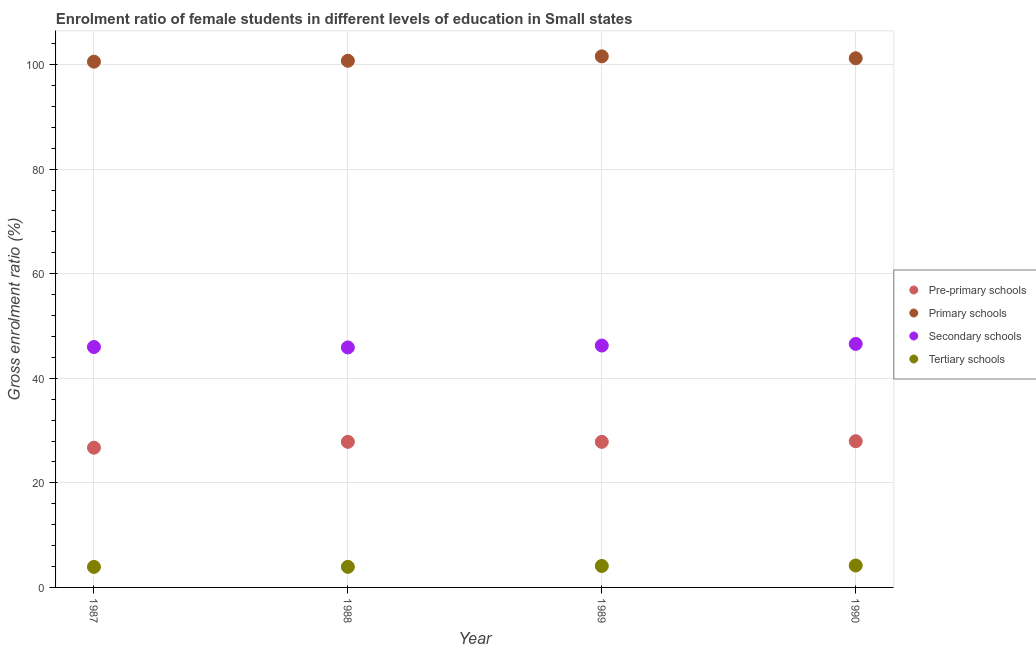How many different coloured dotlines are there?
Ensure brevity in your answer.  4. What is the gross enrolment ratio(male) in tertiary schools in 1990?
Provide a short and direct response. 4.19. Across all years, what is the maximum gross enrolment ratio(male) in primary schools?
Provide a succinct answer. 101.56. Across all years, what is the minimum gross enrolment ratio(male) in tertiary schools?
Offer a terse response. 3.93. In which year was the gross enrolment ratio(male) in primary schools maximum?
Your answer should be compact. 1989. What is the total gross enrolment ratio(male) in tertiary schools in the graph?
Provide a succinct answer. 16.16. What is the difference between the gross enrolment ratio(male) in pre-primary schools in 1988 and that in 1989?
Keep it short and to the point. 0.01. What is the difference between the gross enrolment ratio(male) in tertiary schools in 1989 and the gross enrolment ratio(male) in secondary schools in 1987?
Keep it short and to the point. -41.87. What is the average gross enrolment ratio(male) in tertiary schools per year?
Give a very brief answer. 4.04. In the year 1988, what is the difference between the gross enrolment ratio(male) in secondary schools and gross enrolment ratio(male) in primary schools?
Keep it short and to the point. -54.82. What is the ratio of the gross enrolment ratio(male) in secondary schools in 1989 to that in 1990?
Give a very brief answer. 0.99. Is the gross enrolment ratio(male) in primary schools in 1987 less than that in 1990?
Ensure brevity in your answer.  Yes. Is the difference between the gross enrolment ratio(male) in secondary schools in 1987 and 1988 greater than the difference between the gross enrolment ratio(male) in primary schools in 1987 and 1988?
Give a very brief answer. Yes. What is the difference between the highest and the second highest gross enrolment ratio(male) in tertiary schools?
Your answer should be compact. 0.09. What is the difference between the highest and the lowest gross enrolment ratio(male) in pre-primary schools?
Provide a short and direct response. 1.24. In how many years, is the gross enrolment ratio(male) in pre-primary schools greater than the average gross enrolment ratio(male) in pre-primary schools taken over all years?
Offer a very short reply. 3. Is the sum of the gross enrolment ratio(male) in pre-primary schools in 1987 and 1990 greater than the maximum gross enrolment ratio(male) in secondary schools across all years?
Offer a terse response. Yes. How many years are there in the graph?
Ensure brevity in your answer.  4. What is the difference between two consecutive major ticks on the Y-axis?
Your response must be concise. 20. Where does the legend appear in the graph?
Your response must be concise. Center right. How are the legend labels stacked?
Ensure brevity in your answer.  Vertical. What is the title of the graph?
Your answer should be compact. Enrolment ratio of female students in different levels of education in Small states. What is the label or title of the X-axis?
Your answer should be very brief. Year. What is the label or title of the Y-axis?
Your response must be concise. Gross enrolment ratio (%). What is the Gross enrolment ratio (%) in Pre-primary schools in 1987?
Make the answer very short. 26.72. What is the Gross enrolment ratio (%) of Primary schools in 1987?
Give a very brief answer. 100.54. What is the Gross enrolment ratio (%) of Secondary schools in 1987?
Your response must be concise. 45.98. What is the Gross enrolment ratio (%) in Tertiary schools in 1987?
Your answer should be compact. 3.93. What is the Gross enrolment ratio (%) of Pre-primary schools in 1988?
Make the answer very short. 27.85. What is the Gross enrolment ratio (%) of Primary schools in 1988?
Your response must be concise. 100.71. What is the Gross enrolment ratio (%) of Secondary schools in 1988?
Offer a very short reply. 45.89. What is the Gross enrolment ratio (%) in Tertiary schools in 1988?
Offer a terse response. 3.93. What is the Gross enrolment ratio (%) in Pre-primary schools in 1989?
Your response must be concise. 27.84. What is the Gross enrolment ratio (%) in Primary schools in 1989?
Keep it short and to the point. 101.56. What is the Gross enrolment ratio (%) in Secondary schools in 1989?
Offer a terse response. 46.26. What is the Gross enrolment ratio (%) of Tertiary schools in 1989?
Keep it short and to the point. 4.1. What is the Gross enrolment ratio (%) of Pre-primary schools in 1990?
Your answer should be compact. 27.96. What is the Gross enrolment ratio (%) in Primary schools in 1990?
Make the answer very short. 101.2. What is the Gross enrolment ratio (%) in Secondary schools in 1990?
Keep it short and to the point. 46.57. What is the Gross enrolment ratio (%) in Tertiary schools in 1990?
Your answer should be compact. 4.19. Across all years, what is the maximum Gross enrolment ratio (%) in Pre-primary schools?
Ensure brevity in your answer.  27.96. Across all years, what is the maximum Gross enrolment ratio (%) of Primary schools?
Ensure brevity in your answer.  101.56. Across all years, what is the maximum Gross enrolment ratio (%) in Secondary schools?
Provide a short and direct response. 46.57. Across all years, what is the maximum Gross enrolment ratio (%) in Tertiary schools?
Provide a succinct answer. 4.19. Across all years, what is the minimum Gross enrolment ratio (%) of Pre-primary schools?
Make the answer very short. 26.72. Across all years, what is the minimum Gross enrolment ratio (%) of Primary schools?
Give a very brief answer. 100.54. Across all years, what is the minimum Gross enrolment ratio (%) in Secondary schools?
Your answer should be very brief. 45.89. Across all years, what is the minimum Gross enrolment ratio (%) in Tertiary schools?
Your answer should be compact. 3.93. What is the total Gross enrolment ratio (%) of Pre-primary schools in the graph?
Provide a succinct answer. 110.37. What is the total Gross enrolment ratio (%) in Primary schools in the graph?
Provide a short and direct response. 404.01. What is the total Gross enrolment ratio (%) in Secondary schools in the graph?
Your response must be concise. 184.69. What is the total Gross enrolment ratio (%) of Tertiary schools in the graph?
Make the answer very short. 16.16. What is the difference between the Gross enrolment ratio (%) of Pre-primary schools in 1987 and that in 1988?
Your response must be concise. -1.12. What is the difference between the Gross enrolment ratio (%) of Primary schools in 1987 and that in 1988?
Make the answer very short. -0.17. What is the difference between the Gross enrolment ratio (%) in Secondary schools in 1987 and that in 1988?
Keep it short and to the point. 0.09. What is the difference between the Gross enrolment ratio (%) in Tertiary schools in 1987 and that in 1988?
Ensure brevity in your answer.  -0.01. What is the difference between the Gross enrolment ratio (%) in Pre-primary schools in 1987 and that in 1989?
Offer a terse response. -1.11. What is the difference between the Gross enrolment ratio (%) in Primary schools in 1987 and that in 1989?
Your response must be concise. -1.02. What is the difference between the Gross enrolment ratio (%) of Secondary schools in 1987 and that in 1989?
Ensure brevity in your answer.  -0.28. What is the difference between the Gross enrolment ratio (%) of Tertiary schools in 1987 and that in 1989?
Offer a very short reply. -0.18. What is the difference between the Gross enrolment ratio (%) in Pre-primary schools in 1987 and that in 1990?
Your answer should be compact. -1.24. What is the difference between the Gross enrolment ratio (%) of Primary schools in 1987 and that in 1990?
Your response must be concise. -0.66. What is the difference between the Gross enrolment ratio (%) of Secondary schools in 1987 and that in 1990?
Offer a very short reply. -0.59. What is the difference between the Gross enrolment ratio (%) of Tertiary schools in 1987 and that in 1990?
Your answer should be compact. -0.27. What is the difference between the Gross enrolment ratio (%) in Pre-primary schools in 1988 and that in 1989?
Make the answer very short. 0.01. What is the difference between the Gross enrolment ratio (%) in Primary schools in 1988 and that in 1989?
Keep it short and to the point. -0.85. What is the difference between the Gross enrolment ratio (%) of Secondary schools in 1988 and that in 1989?
Make the answer very short. -0.36. What is the difference between the Gross enrolment ratio (%) of Tertiary schools in 1988 and that in 1989?
Your response must be concise. -0.17. What is the difference between the Gross enrolment ratio (%) of Pre-primary schools in 1988 and that in 1990?
Your response must be concise. -0.11. What is the difference between the Gross enrolment ratio (%) in Primary schools in 1988 and that in 1990?
Give a very brief answer. -0.48. What is the difference between the Gross enrolment ratio (%) of Secondary schools in 1988 and that in 1990?
Ensure brevity in your answer.  -0.68. What is the difference between the Gross enrolment ratio (%) of Tertiary schools in 1988 and that in 1990?
Provide a short and direct response. -0.26. What is the difference between the Gross enrolment ratio (%) of Pre-primary schools in 1989 and that in 1990?
Offer a very short reply. -0.12. What is the difference between the Gross enrolment ratio (%) of Primary schools in 1989 and that in 1990?
Provide a succinct answer. 0.36. What is the difference between the Gross enrolment ratio (%) in Secondary schools in 1989 and that in 1990?
Offer a very short reply. -0.31. What is the difference between the Gross enrolment ratio (%) in Tertiary schools in 1989 and that in 1990?
Keep it short and to the point. -0.09. What is the difference between the Gross enrolment ratio (%) in Pre-primary schools in 1987 and the Gross enrolment ratio (%) in Primary schools in 1988?
Offer a terse response. -73.99. What is the difference between the Gross enrolment ratio (%) in Pre-primary schools in 1987 and the Gross enrolment ratio (%) in Secondary schools in 1988?
Provide a succinct answer. -19.17. What is the difference between the Gross enrolment ratio (%) in Pre-primary schools in 1987 and the Gross enrolment ratio (%) in Tertiary schools in 1988?
Provide a succinct answer. 22.79. What is the difference between the Gross enrolment ratio (%) in Primary schools in 1987 and the Gross enrolment ratio (%) in Secondary schools in 1988?
Offer a terse response. 54.65. What is the difference between the Gross enrolment ratio (%) of Primary schools in 1987 and the Gross enrolment ratio (%) of Tertiary schools in 1988?
Keep it short and to the point. 96.61. What is the difference between the Gross enrolment ratio (%) in Secondary schools in 1987 and the Gross enrolment ratio (%) in Tertiary schools in 1988?
Provide a succinct answer. 42.04. What is the difference between the Gross enrolment ratio (%) in Pre-primary schools in 1987 and the Gross enrolment ratio (%) in Primary schools in 1989?
Ensure brevity in your answer.  -74.84. What is the difference between the Gross enrolment ratio (%) of Pre-primary schools in 1987 and the Gross enrolment ratio (%) of Secondary schools in 1989?
Offer a terse response. -19.53. What is the difference between the Gross enrolment ratio (%) of Pre-primary schools in 1987 and the Gross enrolment ratio (%) of Tertiary schools in 1989?
Give a very brief answer. 22.62. What is the difference between the Gross enrolment ratio (%) in Primary schools in 1987 and the Gross enrolment ratio (%) in Secondary schools in 1989?
Provide a succinct answer. 54.29. What is the difference between the Gross enrolment ratio (%) of Primary schools in 1987 and the Gross enrolment ratio (%) of Tertiary schools in 1989?
Keep it short and to the point. 96.44. What is the difference between the Gross enrolment ratio (%) of Secondary schools in 1987 and the Gross enrolment ratio (%) of Tertiary schools in 1989?
Provide a short and direct response. 41.87. What is the difference between the Gross enrolment ratio (%) in Pre-primary schools in 1987 and the Gross enrolment ratio (%) in Primary schools in 1990?
Your answer should be very brief. -74.47. What is the difference between the Gross enrolment ratio (%) in Pre-primary schools in 1987 and the Gross enrolment ratio (%) in Secondary schools in 1990?
Offer a very short reply. -19.85. What is the difference between the Gross enrolment ratio (%) in Pre-primary schools in 1987 and the Gross enrolment ratio (%) in Tertiary schools in 1990?
Your answer should be very brief. 22.53. What is the difference between the Gross enrolment ratio (%) in Primary schools in 1987 and the Gross enrolment ratio (%) in Secondary schools in 1990?
Give a very brief answer. 53.97. What is the difference between the Gross enrolment ratio (%) in Primary schools in 1987 and the Gross enrolment ratio (%) in Tertiary schools in 1990?
Offer a terse response. 96.35. What is the difference between the Gross enrolment ratio (%) of Secondary schools in 1987 and the Gross enrolment ratio (%) of Tertiary schools in 1990?
Give a very brief answer. 41.78. What is the difference between the Gross enrolment ratio (%) of Pre-primary schools in 1988 and the Gross enrolment ratio (%) of Primary schools in 1989?
Provide a succinct answer. -73.71. What is the difference between the Gross enrolment ratio (%) in Pre-primary schools in 1988 and the Gross enrolment ratio (%) in Secondary schools in 1989?
Keep it short and to the point. -18.41. What is the difference between the Gross enrolment ratio (%) in Pre-primary schools in 1988 and the Gross enrolment ratio (%) in Tertiary schools in 1989?
Your answer should be very brief. 23.74. What is the difference between the Gross enrolment ratio (%) in Primary schools in 1988 and the Gross enrolment ratio (%) in Secondary schools in 1989?
Your response must be concise. 54.46. What is the difference between the Gross enrolment ratio (%) in Primary schools in 1988 and the Gross enrolment ratio (%) in Tertiary schools in 1989?
Ensure brevity in your answer.  96.61. What is the difference between the Gross enrolment ratio (%) of Secondary schools in 1988 and the Gross enrolment ratio (%) of Tertiary schools in 1989?
Offer a terse response. 41.79. What is the difference between the Gross enrolment ratio (%) of Pre-primary schools in 1988 and the Gross enrolment ratio (%) of Primary schools in 1990?
Give a very brief answer. -73.35. What is the difference between the Gross enrolment ratio (%) of Pre-primary schools in 1988 and the Gross enrolment ratio (%) of Secondary schools in 1990?
Provide a succinct answer. -18.72. What is the difference between the Gross enrolment ratio (%) of Pre-primary schools in 1988 and the Gross enrolment ratio (%) of Tertiary schools in 1990?
Your response must be concise. 23.65. What is the difference between the Gross enrolment ratio (%) of Primary schools in 1988 and the Gross enrolment ratio (%) of Secondary schools in 1990?
Ensure brevity in your answer.  54.14. What is the difference between the Gross enrolment ratio (%) of Primary schools in 1988 and the Gross enrolment ratio (%) of Tertiary schools in 1990?
Offer a terse response. 96.52. What is the difference between the Gross enrolment ratio (%) in Secondary schools in 1988 and the Gross enrolment ratio (%) in Tertiary schools in 1990?
Offer a very short reply. 41.7. What is the difference between the Gross enrolment ratio (%) in Pre-primary schools in 1989 and the Gross enrolment ratio (%) in Primary schools in 1990?
Give a very brief answer. -73.36. What is the difference between the Gross enrolment ratio (%) of Pre-primary schools in 1989 and the Gross enrolment ratio (%) of Secondary schools in 1990?
Your answer should be very brief. -18.73. What is the difference between the Gross enrolment ratio (%) of Pre-primary schools in 1989 and the Gross enrolment ratio (%) of Tertiary schools in 1990?
Offer a very short reply. 23.64. What is the difference between the Gross enrolment ratio (%) of Primary schools in 1989 and the Gross enrolment ratio (%) of Secondary schools in 1990?
Make the answer very short. 54.99. What is the difference between the Gross enrolment ratio (%) of Primary schools in 1989 and the Gross enrolment ratio (%) of Tertiary schools in 1990?
Offer a terse response. 97.36. What is the difference between the Gross enrolment ratio (%) in Secondary schools in 1989 and the Gross enrolment ratio (%) in Tertiary schools in 1990?
Your answer should be very brief. 42.06. What is the average Gross enrolment ratio (%) in Pre-primary schools per year?
Keep it short and to the point. 27.59. What is the average Gross enrolment ratio (%) of Primary schools per year?
Offer a terse response. 101. What is the average Gross enrolment ratio (%) of Secondary schools per year?
Your answer should be very brief. 46.17. What is the average Gross enrolment ratio (%) of Tertiary schools per year?
Your answer should be very brief. 4.04. In the year 1987, what is the difference between the Gross enrolment ratio (%) in Pre-primary schools and Gross enrolment ratio (%) in Primary schools?
Your answer should be very brief. -73.82. In the year 1987, what is the difference between the Gross enrolment ratio (%) of Pre-primary schools and Gross enrolment ratio (%) of Secondary schools?
Offer a very short reply. -19.25. In the year 1987, what is the difference between the Gross enrolment ratio (%) of Pre-primary schools and Gross enrolment ratio (%) of Tertiary schools?
Provide a short and direct response. 22.8. In the year 1987, what is the difference between the Gross enrolment ratio (%) of Primary schools and Gross enrolment ratio (%) of Secondary schools?
Provide a short and direct response. 54.57. In the year 1987, what is the difference between the Gross enrolment ratio (%) of Primary schools and Gross enrolment ratio (%) of Tertiary schools?
Provide a short and direct response. 96.62. In the year 1987, what is the difference between the Gross enrolment ratio (%) in Secondary schools and Gross enrolment ratio (%) in Tertiary schools?
Your answer should be very brief. 42.05. In the year 1988, what is the difference between the Gross enrolment ratio (%) in Pre-primary schools and Gross enrolment ratio (%) in Primary schools?
Ensure brevity in your answer.  -72.87. In the year 1988, what is the difference between the Gross enrolment ratio (%) of Pre-primary schools and Gross enrolment ratio (%) of Secondary schools?
Ensure brevity in your answer.  -18.05. In the year 1988, what is the difference between the Gross enrolment ratio (%) in Pre-primary schools and Gross enrolment ratio (%) in Tertiary schools?
Your answer should be very brief. 23.91. In the year 1988, what is the difference between the Gross enrolment ratio (%) in Primary schools and Gross enrolment ratio (%) in Secondary schools?
Offer a very short reply. 54.82. In the year 1988, what is the difference between the Gross enrolment ratio (%) of Primary schools and Gross enrolment ratio (%) of Tertiary schools?
Ensure brevity in your answer.  96.78. In the year 1988, what is the difference between the Gross enrolment ratio (%) in Secondary schools and Gross enrolment ratio (%) in Tertiary schools?
Provide a succinct answer. 41.96. In the year 1989, what is the difference between the Gross enrolment ratio (%) in Pre-primary schools and Gross enrolment ratio (%) in Primary schools?
Keep it short and to the point. -73.72. In the year 1989, what is the difference between the Gross enrolment ratio (%) in Pre-primary schools and Gross enrolment ratio (%) in Secondary schools?
Offer a terse response. -18.42. In the year 1989, what is the difference between the Gross enrolment ratio (%) of Pre-primary schools and Gross enrolment ratio (%) of Tertiary schools?
Your response must be concise. 23.73. In the year 1989, what is the difference between the Gross enrolment ratio (%) of Primary schools and Gross enrolment ratio (%) of Secondary schools?
Provide a short and direct response. 55.3. In the year 1989, what is the difference between the Gross enrolment ratio (%) in Primary schools and Gross enrolment ratio (%) in Tertiary schools?
Offer a terse response. 97.46. In the year 1989, what is the difference between the Gross enrolment ratio (%) in Secondary schools and Gross enrolment ratio (%) in Tertiary schools?
Your answer should be very brief. 42.15. In the year 1990, what is the difference between the Gross enrolment ratio (%) in Pre-primary schools and Gross enrolment ratio (%) in Primary schools?
Keep it short and to the point. -73.24. In the year 1990, what is the difference between the Gross enrolment ratio (%) of Pre-primary schools and Gross enrolment ratio (%) of Secondary schools?
Offer a very short reply. -18.61. In the year 1990, what is the difference between the Gross enrolment ratio (%) of Pre-primary schools and Gross enrolment ratio (%) of Tertiary schools?
Provide a short and direct response. 23.77. In the year 1990, what is the difference between the Gross enrolment ratio (%) in Primary schools and Gross enrolment ratio (%) in Secondary schools?
Keep it short and to the point. 54.63. In the year 1990, what is the difference between the Gross enrolment ratio (%) in Primary schools and Gross enrolment ratio (%) in Tertiary schools?
Offer a terse response. 97. In the year 1990, what is the difference between the Gross enrolment ratio (%) in Secondary schools and Gross enrolment ratio (%) in Tertiary schools?
Ensure brevity in your answer.  42.37. What is the ratio of the Gross enrolment ratio (%) in Pre-primary schools in 1987 to that in 1988?
Your response must be concise. 0.96. What is the ratio of the Gross enrolment ratio (%) in Primary schools in 1987 to that in 1988?
Provide a short and direct response. 1. What is the ratio of the Gross enrolment ratio (%) in Tertiary schools in 1987 to that in 1988?
Give a very brief answer. 1. What is the ratio of the Gross enrolment ratio (%) in Pre-primary schools in 1987 to that in 1989?
Offer a terse response. 0.96. What is the ratio of the Gross enrolment ratio (%) in Tertiary schools in 1987 to that in 1989?
Offer a very short reply. 0.96. What is the ratio of the Gross enrolment ratio (%) of Pre-primary schools in 1987 to that in 1990?
Make the answer very short. 0.96. What is the ratio of the Gross enrolment ratio (%) in Secondary schools in 1987 to that in 1990?
Offer a very short reply. 0.99. What is the ratio of the Gross enrolment ratio (%) in Tertiary schools in 1987 to that in 1990?
Provide a short and direct response. 0.94. What is the ratio of the Gross enrolment ratio (%) of Pre-primary schools in 1988 to that in 1989?
Offer a terse response. 1. What is the ratio of the Gross enrolment ratio (%) of Secondary schools in 1988 to that in 1989?
Offer a terse response. 0.99. What is the ratio of the Gross enrolment ratio (%) of Secondary schools in 1988 to that in 1990?
Make the answer very short. 0.99. What is the ratio of the Gross enrolment ratio (%) of Tertiary schools in 1988 to that in 1990?
Ensure brevity in your answer.  0.94. What is the ratio of the Gross enrolment ratio (%) in Tertiary schools in 1989 to that in 1990?
Give a very brief answer. 0.98. What is the difference between the highest and the second highest Gross enrolment ratio (%) of Pre-primary schools?
Offer a terse response. 0.11. What is the difference between the highest and the second highest Gross enrolment ratio (%) in Primary schools?
Give a very brief answer. 0.36. What is the difference between the highest and the second highest Gross enrolment ratio (%) in Secondary schools?
Make the answer very short. 0.31. What is the difference between the highest and the second highest Gross enrolment ratio (%) in Tertiary schools?
Ensure brevity in your answer.  0.09. What is the difference between the highest and the lowest Gross enrolment ratio (%) of Pre-primary schools?
Your answer should be very brief. 1.24. What is the difference between the highest and the lowest Gross enrolment ratio (%) in Primary schools?
Your response must be concise. 1.02. What is the difference between the highest and the lowest Gross enrolment ratio (%) in Secondary schools?
Your answer should be very brief. 0.68. What is the difference between the highest and the lowest Gross enrolment ratio (%) in Tertiary schools?
Offer a very short reply. 0.27. 